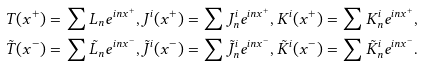<formula> <loc_0><loc_0><loc_500><loc_500>T ( x ^ { + } ) & = \sum { L _ { n } } e ^ { i n x ^ { + } } , J ^ { i } ( x ^ { + } ) = \sum { J ^ { i } _ { n } } e ^ { i n x ^ { + } } , K ^ { i } ( x ^ { + } ) = \sum { K ^ { i } _ { n } } e ^ { i n x ^ { + } } , \\ \tilde { T } ( x ^ { - } ) & = \sum { \tilde { L } _ { n } } e ^ { i n x ^ { - } } , \tilde { J } ^ { i } ( x ^ { - } ) = \sum { \tilde { J } ^ { i } _ { n } } e ^ { i n x ^ { - } } , \tilde { K } ^ { i } ( x ^ { - } ) = \sum { \tilde { K } ^ { i } _ { n } } e ^ { i n x ^ { - } } .</formula> 